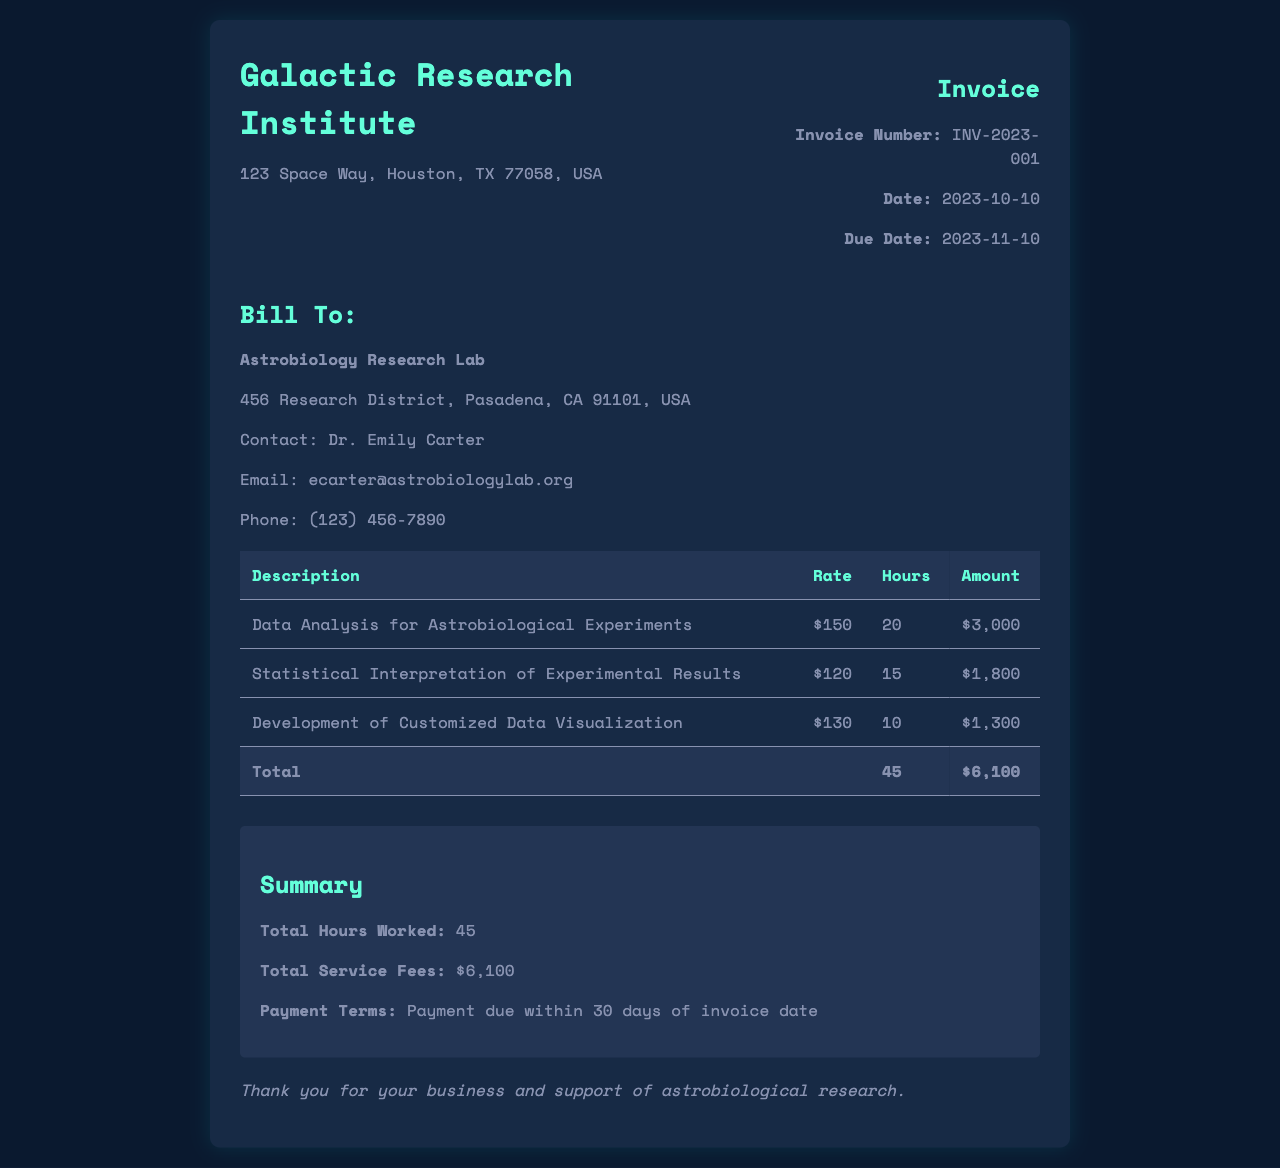What is the invoice number? The invoice number is specified under the invoice information section of the document.
Answer: INV-2023-001 What is the total amount due? The total amount due is calculated from the total service fees listed in the summary section.
Answer: $6,100 How many hours were worked in total? The total hours worked is summarized in the invoice under the summary section.
Answer: 45 What is the hourly rate for data analysis? The hourly rate for data analysis is provided in the table of services rendered.
Answer: $150 What is the due date for payment? The due date is mentioned in the invoice information section of the document.
Answer: 2023-11-10 What service corresponds to the highest amount charged? The service with the highest amount is identified in the services table and its corresponding charge is taken into account.
Answer: Data Analysis for Astrobiological Experiments What is the contact email for the client? The contact email is listed in the client information section of the document.
Answer: ecarter@astrobiologylab.org What are the payment terms specified in the invoice? The payment terms are explicitly mentioned in the summary section of the invoice.
Answer: Payment due within 30 days of invoice date 